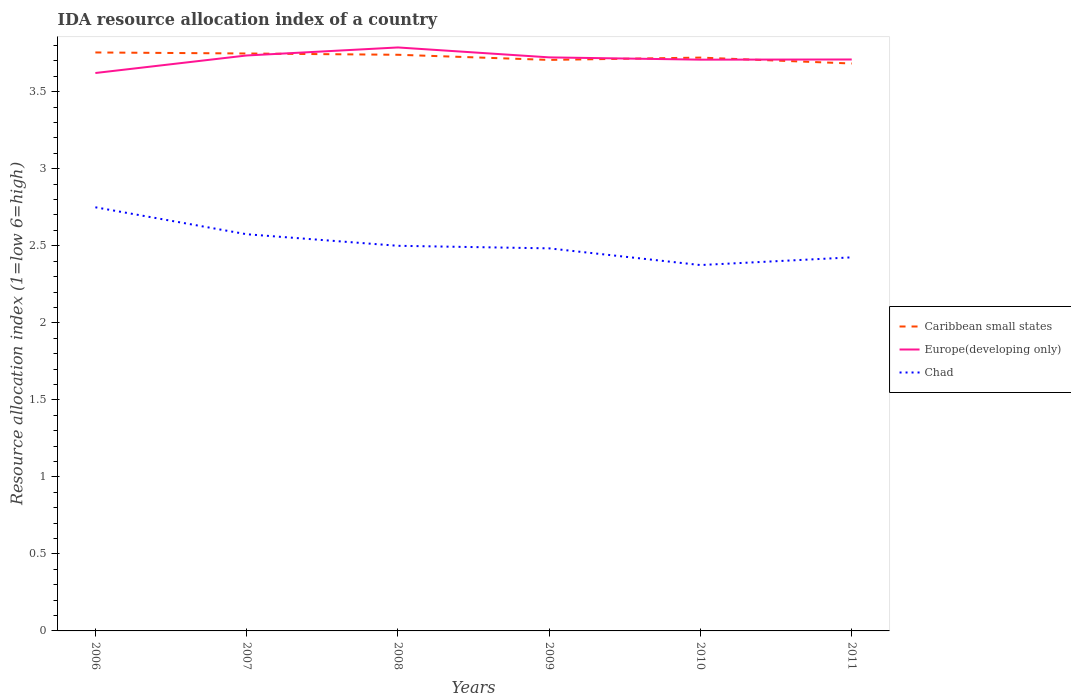Does the line corresponding to Chad intersect with the line corresponding to Europe(developing only)?
Offer a very short reply. No. Is the number of lines equal to the number of legend labels?
Offer a very short reply. Yes. Across all years, what is the maximum IDA resource allocation index in Europe(developing only)?
Give a very brief answer. 3.62. What is the total IDA resource allocation index in Caribbean small states in the graph?
Ensure brevity in your answer.  0.05. Is the IDA resource allocation index in Caribbean small states strictly greater than the IDA resource allocation index in Europe(developing only) over the years?
Your answer should be compact. No. How many lines are there?
Provide a succinct answer. 3. What is the difference between two consecutive major ticks on the Y-axis?
Offer a terse response. 0.5. Are the values on the major ticks of Y-axis written in scientific E-notation?
Offer a very short reply. No. Does the graph contain any zero values?
Make the answer very short. No. How many legend labels are there?
Your response must be concise. 3. What is the title of the graph?
Your response must be concise. IDA resource allocation index of a country. What is the label or title of the X-axis?
Make the answer very short. Years. What is the label or title of the Y-axis?
Make the answer very short. Resource allocation index (1=low 6=high). What is the Resource allocation index (1=low 6=high) in Caribbean small states in 2006?
Offer a very short reply. 3.75. What is the Resource allocation index (1=low 6=high) in Europe(developing only) in 2006?
Give a very brief answer. 3.62. What is the Resource allocation index (1=low 6=high) of Chad in 2006?
Provide a short and direct response. 2.75. What is the Resource allocation index (1=low 6=high) of Caribbean small states in 2007?
Provide a succinct answer. 3.75. What is the Resource allocation index (1=low 6=high) in Europe(developing only) in 2007?
Your answer should be compact. 3.74. What is the Resource allocation index (1=low 6=high) in Chad in 2007?
Ensure brevity in your answer.  2.58. What is the Resource allocation index (1=low 6=high) of Caribbean small states in 2008?
Your answer should be very brief. 3.74. What is the Resource allocation index (1=low 6=high) in Europe(developing only) in 2008?
Keep it short and to the point. 3.79. What is the Resource allocation index (1=low 6=high) in Chad in 2008?
Offer a very short reply. 2.5. What is the Resource allocation index (1=low 6=high) in Caribbean small states in 2009?
Your answer should be compact. 3.71. What is the Resource allocation index (1=low 6=high) of Europe(developing only) in 2009?
Make the answer very short. 3.72. What is the Resource allocation index (1=low 6=high) in Chad in 2009?
Offer a terse response. 2.48. What is the Resource allocation index (1=low 6=high) in Caribbean small states in 2010?
Ensure brevity in your answer.  3.72. What is the Resource allocation index (1=low 6=high) of Europe(developing only) in 2010?
Give a very brief answer. 3.71. What is the Resource allocation index (1=low 6=high) in Chad in 2010?
Your answer should be compact. 2.38. What is the Resource allocation index (1=low 6=high) of Caribbean small states in 2011?
Ensure brevity in your answer.  3.68. What is the Resource allocation index (1=low 6=high) of Europe(developing only) in 2011?
Your answer should be compact. 3.71. What is the Resource allocation index (1=low 6=high) in Chad in 2011?
Offer a terse response. 2.42. Across all years, what is the maximum Resource allocation index (1=low 6=high) of Caribbean small states?
Make the answer very short. 3.75. Across all years, what is the maximum Resource allocation index (1=low 6=high) in Europe(developing only)?
Make the answer very short. 3.79. Across all years, what is the maximum Resource allocation index (1=low 6=high) in Chad?
Provide a succinct answer. 2.75. Across all years, what is the minimum Resource allocation index (1=low 6=high) of Caribbean small states?
Offer a terse response. 3.68. Across all years, what is the minimum Resource allocation index (1=low 6=high) in Europe(developing only)?
Your answer should be very brief. 3.62. Across all years, what is the minimum Resource allocation index (1=low 6=high) in Chad?
Ensure brevity in your answer.  2.38. What is the total Resource allocation index (1=low 6=high) of Caribbean small states in the graph?
Offer a terse response. 22.36. What is the total Resource allocation index (1=low 6=high) of Europe(developing only) in the graph?
Give a very brief answer. 22.29. What is the total Resource allocation index (1=low 6=high) in Chad in the graph?
Your answer should be very brief. 15.11. What is the difference between the Resource allocation index (1=low 6=high) of Caribbean small states in 2006 and that in 2007?
Your answer should be compact. 0.01. What is the difference between the Resource allocation index (1=low 6=high) in Europe(developing only) in 2006 and that in 2007?
Offer a terse response. -0.11. What is the difference between the Resource allocation index (1=low 6=high) in Chad in 2006 and that in 2007?
Offer a terse response. 0.17. What is the difference between the Resource allocation index (1=low 6=high) in Caribbean small states in 2006 and that in 2008?
Offer a terse response. 0.01. What is the difference between the Resource allocation index (1=low 6=high) in Europe(developing only) in 2006 and that in 2008?
Provide a short and direct response. -0.17. What is the difference between the Resource allocation index (1=low 6=high) of Caribbean small states in 2006 and that in 2009?
Offer a terse response. 0.05. What is the difference between the Resource allocation index (1=low 6=high) of Europe(developing only) in 2006 and that in 2009?
Provide a succinct answer. -0.1. What is the difference between the Resource allocation index (1=low 6=high) in Chad in 2006 and that in 2009?
Your answer should be compact. 0.27. What is the difference between the Resource allocation index (1=low 6=high) of Europe(developing only) in 2006 and that in 2010?
Provide a short and direct response. -0.09. What is the difference between the Resource allocation index (1=low 6=high) in Caribbean small states in 2006 and that in 2011?
Your answer should be compact. 0.07. What is the difference between the Resource allocation index (1=low 6=high) in Europe(developing only) in 2006 and that in 2011?
Your answer should be compact. -0.09. What is the difference between the Resource allocation index (1=low 6=high) in Chad in 2006 and that in 2011?
Ensure brevity in your answer.  0.33. What is the difference between the Resource allocation index (1=low 6=high) in Caribbean small states in 2007 and that in 2008?
Provide a succinct answer. 0.01. What is the difference between the Resource allocation index (1=low 6=high) in Europe(developing only) in 2007 and that in 2008?
Offer a very short reply. -0.05. What is the difference between the Resource allocation index (1=low 6=high) of Chad in 2007 and that in 2008?
Make the answer very short. 0.07. What is the difference between the Resource allocation index (1=low 6=high) in Caribbean small states in 2007 and that in 2009?
Ensure brevity in your answer.  0.04. What is the difference between the Resource allocation index (1=low 6=high) of Europe(developing only) in 2007 and that in 2009?
Provide a short and direct response. 0.01. What is the difference between the Resource allocation index (1=low 6=high) in Chad in 2007 and that in 2009?
Your response must be concise. 0.09. What is the difference between the Resource allocation index (1=low 6=high) in Caribbean small states in 2007 and that in 2010?
Your answer should be compact. 0.03. What is the difference between the Resource allocation index (1=low 6=high) in Europe(developing only) in 2007 and that in 2010?
Keep it short and to the point. 0.03. What is the difference between the Resource allocation index (1=low 6=high) in Caribbean small states in 2007 and that in 2011?
Make the answer very short. 0.07. What is the difference between the Resource allocation index (1=low 6=high) in Europe(developing only) in 2007 and that in 2011?
Your response must be concise. 0.03. What is the difference between the Resource allocation index (1=low 6=high) in Europe(developing only) in 2008 and that in 2009?
Offer a very short reply. 0.06. What is the difference between the Resource allocation index (1=low 6=high) of Chad in 2008 and that in 2009?
Make the answer very short. 0.02. What is the difference between the Resource allocation index (1=low 6=high) of Caribbean small states in 2008 and that in 2010?
Your response must be concise. 0.02. What is the difference between the Resource allocation index (1=low 6=high) of Europe(developing only) in 2008 and that in 2010?
Give a very brief answer. 0.08. What is the difference between the Resource allocation index (1=low 6=high) of Chad in 2008 and that in 2010?
Your answer should be very brief. 0.12. What is the difference between the Resource allocation index (1=low 6=high) of Caribbean small states in 2008 and that in 2011?
Offer a terse response. 0.06. What is the difference between the Resource allocation index (1=low 6=high) in Europe(developing only) in 2008 and that in 2011?
Provide a short and direct response. 0.08. What is the difference between the Resource allocation index (1=low 6=high) of Chad in 2008 and that in 2011?
Make the answer very short. 0.07. What is the difference between the Resource allocation index (1=low 6=high) in Caribbean small states in 2009 and that in 2010?
Give a very brief answer. -0.01. What is the difference between the Resource allocation index (1=low 6=high) in Europe(developing only) in 2009 and that in 2010?
Provide a succinct answer. 0.01. What is the difference between the Resource allocation index (1=low 6=high) in Chad in 2009 and that in 2010?
Ensure brevity in your answer.  0.11. What is the difference between the Resource allocation index (1=low 6=high) of Caribbean small states in 2009 and that in 2011?
Your answer should be very brief. 0.02. What is the difference between the Resource allocation index (1=low 6=high) in Europe(developing only) in 2009 and that in 2011?
Offer a very short reply. 0.01. What is the difference between the Resource allocation index (1=low 6=high) in Chad in 2009 and that in 2011?
Provide a short and direct response. 0.06. What is the difference between the Resource allocation index (1=low 6=high) of Caribbean small states in 2010 and that in 2011?
Offer a very short reply. 0.04. What is the difference between the Resource allocation index (1=low 6=high) in Europe(developing only) in 2010 and that in 2011?
Provide a succinct answer. -0. What is the difference between the Resource allocation index (1=low 6=high) in Chad in 2010 and that in 2011?
Ensure brevity in your answer.  -0.05. What is the difference between the Resource allocation index (1=low 6=high) of Caribbean small states in 2006 and the Resource allocation index (1=low 6=high) of Europe(developing only) in 2007?
Provide a short and direct response. 0.02. What is the difference between the Resource allocation index (1=low 6=high) in Caribbean small states in 2006 and the Resource allocation index (1=low 6=high) in Chad in 2007?
Offer a very short reply. 1.18. What is the difference between the Resource allocation index (1=low 6=high) of Europe(developing only) in 2006 and the Resource allocation index (1=low 6=high) of Chad in 2007?
Keep it short and to the point. 1.05. What is the difference between the Resource allocation index (1=low 6=high) of Caribbean small states in 2006 and the Resource allocation index (1=low 6=high) of Europe(developing only) in 2008?
Your answer should be compact. -0.03. What is the difference between the Resource allocation index (1=low 6=high) in Caribbean small states in 2006 and the Resource allocation index (1=low 6=high) in Chad in 2008?
Keep it short and to the point. 1.25. What is the difference between the Resource allocation index (1=low 6=high) in Europe(developing only) in 2006 and the Resource allocation index (1=low 6=high) in Chad in 2008?
Offer a very short reply. 1.12. What is the difference between the Resource allocation index (1=low 6=high) of Caribbean small states in 2006 and the Resource allocation index (1=low 6=high) of Europe(developing only) in 2009?
Provide a succinct answer. 0.03. What is the difference between the Resource allocation index (1=low 6=high) in Caribbean small states in 2006 and the Resource allocation index (1=low 6=high) in Chad in 2009?
Provide a short and direct response. 1.27. What is the difference between the Resource allocation index (1=low 6=high) in Europe(developing only) in 2006 and the Resource allocation index (1=low 6=high) in Chad in 2009?
Make the answer very short. 1.14. What is the difference between the Resource allocation index (1=low 6=high) of Caribbean small states in 2006 and the Resource allocation index (1=low 6=high) of Europe(developing only) in 2010?
Ensure brevity in your answer.  0.05. What is the difference between the Resource allocation index (1=low 6=high) of Caribbean small states in 2006 and the Resource allocation index (1=low 6=high) of Chad in 2010?
Your answer should be compact. 1.38. What is the difference between the Resource allocation index (1=low 6=high) in Europe(developing only) in 2006 and the Resource allocation index (1=low 6=high) in Chad in 2010?
Your response must be concise. 1.25. What is the difference between the Resource allocation index (1=low 6=high) of Caribbean small states in 2006 and the Resource allocation index (1=low 6=high) of Europe(developing only) in 2011?
Your answer should be very brief. 0.05. What is the difference between the Resource allocation index (1=low 6=high) in Caribbean small states in 2006 and the Resource allocation index (1=low 6=high) in Chad in 2011?
Ensure brevity in your answer.  1.33. What is the difference between the Resource allocation index (1=low 6=high) in Europe(developing only) in 2006 and the Resource allocation index (1=low 6=high) in Chad in 2011?
Make the answer very short. 1.2. What is the difference between the Resource allocation index (1=low 6=high) of Caribbean small states in 2007 and the Resource allocation index (1=low 6=high) of Europe(developing only) in 2008?
Provide a short and direct response. -0.04. What is the difference between the Resource allocation index (1=low 6=high) of Caribbean small states in 2007 and the Resource allocation index (1=low 6=high) of Chad in 2008?
Provide a succinct answer. 1.25. What is the difference between the Resource allocation index (1=low 6=high) of Europe(developing only) in 2007 and the Resource allocation index (1=low 6=high) of Chad in 2008?
Make the answer very short. 1.24. What is the difference between the Resource allocation index (1=low 6=high) of Caribbean small states in 2007 and the Resource allocation index (1=low 6=high) of Europe(developing only) in 2009?
Give a very brief answer. 0.03. What is the difference between the Resource allocation index (1=low 6=high) in Caribbean small states in 2007 and the Resource allocation index (1=low 6=high) in Chad in 2009?
Give a very brief answer. 1.26. What is the difference between the Resource allocation index (1=low 6=high) in Europe(developing only) in 2007 and the Resource allocation index (1=low 6=high) in Chad in 2009?
Keep it short and to the point. 1.25. What is the difference between the Resource allocation index (1=low 6=high) of Caribbean small states in 2007 and the Resource allocation index (1=low 6=high) of Chad in 2010?
Your answer should be very brief. 1.37. What is the difference between the Resource allocation index (1=low 6=high) in Europe(developing only) in 2007 and the Resource allocation index (1=low 6=high) in Chad in 2010?
Your answer should be very brief. 1.36. What is the difference between the Resource allocation index (1=low 6=high) of Caribbean small states in 2007 and the Resource allocation index (1=low 6=high) of Europe(developing only) in 2011?
Your answer should be very brief. 0.04. What is the difference between the Resource allocation index (1=low 6=high) in Caribbean small states in 2007 and the Resource allocation index (1=low 6=high) in Chad in 2011?
Make the answer very short. 1.32. What is the difference between the Resource allocation index (1=low 6=high) in Europe(developing only) in 2007 and the Resource allocation index (1=low 6=high) in Chad in 2011?
Ensure brevity in your answer.  1.31. What is the difference between the Resource allocation index (1=low 6=high) in Caribbean small states in 2008 and the Resource allocation index (1=low 6=high) in Europe(developing only) in 2009?
Give a very brief answer. 0.02. What is the difference between the Resource allocation index (1=low 6=high) of Caribbean small states in 2008 and the Resource allocation index (1=low 6=high) of Chad in 2009?
Your answer should be compact. 1.26. What is the difference between the Resource allocation index (1=low 6=high) of Europe(developing only) in 2008 and the Resource allocation index (1=low 6=high) of Chad in 2009?
Your answer should be compact. 1.3. What is the difference between the Resource allocation index (1=low 6=high) of Caribbean small states in 2008 and the Resource allocation index (1=low 6=high) of Europe(developing only) in 2010?
Your response must be concise. 0.03. What is the difference between the Resource allocation index (1=low 6=high) of Caribbean small states in 2008 and the Resource allocation index (1=low 6=high) of Chad in 2010?
Your answer should be compact. 1.36. What is the difference between the Resource allocation index (1=low 6=high) in Europe(developing only) in 2008 and the Resource allocation index (1=low 6=high) in Chad in 2010?
Offer a terse response. 1.41. What is the difference between the Resource allocation index (1=low 6=high) in Caribbean small states in 2008 and the Resource allocation index (1=low 6=high) in Europe(developing only) in 2011?
Your answer should be very brief. 0.03. What is the difference between the Resource allocation index (1=low 6=high) in Caribbean small states in 2008 and the Resource allocation index (1=low 6=high) in Chad in 2011?
Provide a short and direct response. 1.31. What is the difference between the Resource allocation index (1=low 6=high) in Europe(developing only) in 2008 and the Resource allocation index (1=low 6=high) in Chad in 2011?
Provide a succinct answer. 1.36. What is the difference between the Resource allocation index (1=low 6=high) in Caribbean small states in 2009 and the Resource allocation index (1=low 6=high) in Europe(developing only) in 2010?
Offer a very short reply. -0. What is the difference between the Resource allocation index (1=low 6=high) in Caribbean small states in 2009 and the Resource allocation index (1=low 6=high) in Chad in 2010?
Make the answer very short. 1.33. What is the difference between the Resource allocation index (1=low 6=high) of Europe(developing only) in 2009 and the Resource allocation index (1=low 6=high) of Chad in 2010?
Your answer should be very brief. 1.35. What is the difference between the Resource allocation index (1=low 6=high) in Caribbean small states in 2009 and the Resource allocation index (1=low 6=high) in Europe(developing only) in 2011?
Provide a succinct answer. -0. What is the difference between the Resource allocation index (1=low 6=high) in Caribbean small states in 2009 and the Resource allocation index (1=low 6=high) in Chad in 2011?
Provide a succinct answer. 1.28. What is the difference between the Resource allocation index (1=low 6=high) of Europe(developing only) in 2009 and the Resource allocation index (1=low 6=high) of Chad in 2011?
Your answer should be compact. 1.3. What is the difference between the Resource allocation index (1=low 6=high) in Caribbean small states in 2010 and the Resource allocation index (1=low 6=high) in Europe(developing only) in 2011?
Your response must be concise. 0.01. What is the difference between the Resource allocation index (1=low 6=high) of Caribbean small states in 2010 and the Resource allocation index (1=low 6=high) of Chad in 2011?
Your answer should be compact. 1.3. What is the difference between the Resource allocation index (1=low 6=high) in Europe(developing only) in 2010 and the Resource allocation index (1=low 6=high) in Chad in 2011?
Make the answer very short. 1.28. What is the average Resource allocation index (1=low 6=high) of Caribbean small states per year?
Your response must be concise. 3.73. What is the average Resource allocation index (1=low 6=high) in Europe(developing only) per year?
Your answer should be very brief. 3.71. What is the average Resource allocation index (1=low 6=high) in Chad per year?
Keep it short and to the point. 2.52. In the year 2006, what is the difference between the Resource allocation index (1=low 6=high) of Caribbean small states and Resource allocation index (1=low 6=high) of Europe(developing only)?
Your response must be concise. 0.13. In the year 2006, what is the difference between the Resource allocation index (1=low 6=high) in Caribbean small states and Resource allocation index (1=low 6=high) in Chad?
Make the answer very short. 1. In the year 2006, what is the difference between the Resource allocation index (1=low 6=high) in Europe(developing only) and Resource allocation index (1=low 6=high) in Chad?
Provide a short and direct response. 0.87. In the year 2007, what is the difference between the Resource allocation index (1=low 6=high) in Caribbean small states and Resource allocation index (1=low 6=high) in Europe(developing only)?
Your response must be concise. 0.01. In the year 2007, what is the difference between the Resource allocation index (1=low 6=high) in Caribbean small states and Resource allocation index (1=low 6=high) in Chad?
Give a very brief answer. 1.17. In the year 2007, what is the difference between the Resource allocation index (1=low 6=high) of Europe(developing only) and Resource allocation index (1=low 6=high) of Chad?
Your response must be concise. 1.16. In the year 2008, what is the difference between the Resource allocation index (1=low 6=high) in Caribbean small states and Resource allocation index (1=low 6=high) in Europe(developing only)?
Provide a succinct answer. -0.05. In the year 2008, what is the difference between the Resource allocation index (1=low 6=high) of Caribbean small states and Resource allocation index (1=low 6=high) of Chad?
Your answer should be very brief. 1.24. In the year 2008, what is the difference between the Resource allocation index (1=low 6=high) of Europe(developing only) and Resource allocation index (1=low 6=high) of Chad?
Ensure brevity in your answer.  1.29. In the year 2009, what is the difference between the Resource allocation index (1=low 6=high) in Caribbean small states and Resource allocation index (1=low 6=high) in Europe(developing only)?
Give a very brief answer. -0.02. In the year 2009, what is the difference between the Resource allocation index (1=low 6=high) in Caribbean small states and Resource allocation index (1=low 6=high) in Chad?
Keep it short and to the point. 1.22. In the year 2009, what is the difference between the Resource allocation index (1=low 6=high) in Europe(developing only) and Resource allocation index (1=low 6=high) in Chad?
Keep it short and to the point. 1.24. In the year 2010, what is the difference between the Resource allocation index (1=low 6=high) in Caribbean small states and Resource allocation index (1=low 6=high) in Europe(developing only)?
Provide a short and direct response. 0.01. In the year 2010, what is the difference between the Resource allocation index (1=low 6=high) in Caribbean small states and Resource allocation index (1=low 6=high) in Chad?
Keep it short and to the point. 1.35. In the year 2011, what is the difference between the Resource allocation index (1=low 6=high) in Caribbean small states and Resource allocation index (1=low 6=high) in Europe(developing only)?
Your response must be concise. -0.03. In the year 2011, what is the difference between the Resource allocation index (1=low 6=high) of Caribbean small states and Resource allocation index (1=low 6=high) of Chad?
Offer a very short reply. 1.26. In the year 2011, what is the difference between the Resource allocation index (1=low 6=high) of Europe(developing only) and Resource allocation index (1=low 6=high) of Chad?
Your answer should be very brief. 1.28. What is the ratio of the Resource allocation index (1=low 6=high) of Europe(developing only) in 2006 to that in 2007?
Offer a terse response. 0.97. What is the ratio of the Resource allocation index (1=low 6=high) of Chad in 2006 to that in 2007?
Your answer should be compact. 1.07. What is the ratio of the Resource allocation index (1=low 6=high) of Caribbean small states in 2006 to that in 2008?
Offer a very short reply. 1. What is the ratio of the Resource allocation index (1=low 6=high) in Europe(developing only) in 2006 to that in 2008?
Give a very brief answer. 0.96. What is the ratio of the Resource allocation index (1=low 6=high) of Chad in 2006 to that in 2008?
Provide a succinct answer. 1.1. What is the ratio of the Resource allocation index (1=low 6=high) of Caribbean small states in 2006 to that in 2009?
Provide a short and direct response. 1.01. What is the ratio of the Resource allocation index (1=low 6=high) in Europe(developing only) in 2006 to that in 2009?
Your answer should be very brief. 0.97. What is the ratio of the Resource allocation index (1=low 6=high) in Chad in 2006 to that in 2009?
Give a very brief answer. 1.11. What is the ratio of the Resource allocation index (1=low 6=high) of Caribbean small states in 2006 to that in 2010?
Make the answer very short. 1.01. What is the ratio of the Resource allocation index (1=low 6=high) of Europe(developing only) in 2006 to that in 2010?
Give a very brief answer. 0.98. What is the ratio of the Resource allocation index (1=low 6=high) in Chad in 2006 to that in 2010?
Ensure brevity in your answer.  1.16. What is the ratio of the Resource allocation index (1=low 6=high) of Caribbean small states in 2006 to that in 2011?
Provide a short and direct response. 1.02. What is the ratio of the Resource allocation index (1=low 6=high) of Europe(developing only) in 2006 to that in 2011?
Your answer should be very brief. 0.98. What is the ratio of the Resource allocation index (1=low 6=high) of Chad in 2006 to that in 2011?
Keep it short and to the point. 1.13. What is the ratio of the Resource allocation index (1=low 6=high) in Europe(developing only) in 2007 to that in 2008?
Offer a very short reply. 0.99. What is the ratio of the Resource allocation index (1=low 6=high) of Caribbean small states in 2007 to that in 2009?
Your answer should be very brief. 1.01. What is the ratio of the Resource allocation index (1=low 6=high) of Chad in 2007 to that in 2009?
Give a very brief answer. 1.04. What is the ratio of the Resource allocation index (1=low 6=high) of Caribbean small states in 2007 to that in 2010?
Make the answer very short. 1.01. What is the ratio of the Resource allocation index (1=low 6=high) of Europe(developing only) in 2007 to that in 2010?
Provide a short and direct response. 1.01. What is the ratio of the Resource allocation index (1=low 6=high) in Chad in 2007 to that in 2010?
Your answer should be very brief. 1.08. What is the ratio of the Resource allocation index (1=low 6=high) of Caribbean small states in 2007 to that in 2011?
Ensure brevity in your answer.  1.02. What is the ratio of the Resource allocation index (1=low 6=high) of Chad in 2007 to that in 2011?
Keep it short and to the point. 1.06. What is the ratio of the Resource allocation index (1=low 6=high) of Europe(developing only) in 2008 to that in 2009?
Provide a short and direct response. 1.02. What is the ratio of the Resource allocation index (1=low 6=high) in Europe(developing only) in 2008 to that in 2010?
Make the answer very short. 1.02. What is the ratio of the Resource allocation index (1=low 6=high) in Chad in 2008 to that in 2010?
Offer a very short reply. 1.05. What is the ratio of the Resource allocation index (1=low 6=high) of Caribbean small states in 2008 to that in 2011?
Your answer should be compact. 1.02. What is the ratio of the Resource allocation index (1=low 6=high) in Europe(developing only) in 2008 to that in 2011?
Ensure brevity in your answer.  1.02. What is the ratio of the Resource allocation index (1=low 6=high) in Chad in 2008 to that in 2011?
Give a very brief answer. 1.03. What is the ratio of the Resource allocation index (1=low 6=high) in Europe(developing only) in 2009 to that in 2010?
Give a very brief answer. 1. What is the ratio of the Resource allocation index (1=low 6=high) in Chad in 2009 to that in 2010?
Provide a short and direct response. 1.05. What is the ratio of the Resource allocation index (1=low 6=high) of Chad in 2009 to that in 2011?
Your answer should be very brief. 1.02. What is the ratio of the Resource allocation index (1=low 6=high) of Caribbean small states in 2010 to that in 2011?
Your answer should be compact. 1.01. What is the ratio of the Resource allocation index (1=low 6=high) of Europe(developing only) in 2010 to that in 2011?
Offer a very short reply. 1. What is the ratio of the Resource allocation index (1=low 6=high) of Chad in 2010 to that in 2011?
Provide a short and direct response. 0.98. What is the difference between the highest and the second highest Resource allocation index (1=low 6=high) of Caribbean small states?
Your answer should be compact. 0.01. What is the difference between the highest and the second highest Resource allocation index (1=low 6=high) of Europe(developing only)?
Provide a succinct answer. 0.05. What is the difference between the highest and the second highest Resource allocation index (1=low 6=high) in Chad?
Give a very brief answer. 0.17. What is the difference between the highest and the lowest Resource allocation index (1=low 6=high) in Caribbean small states?
Ensure brevity in your answer.  0.07. What is the difference between the highest and the lowest Resource allocation index (1=low 6=high) in Europe(developing only)?
Give a very brief answer. 0.17. 